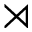<formula> <loc_0><loc_0><loc_500><loc_500>\rtimes</formula> 